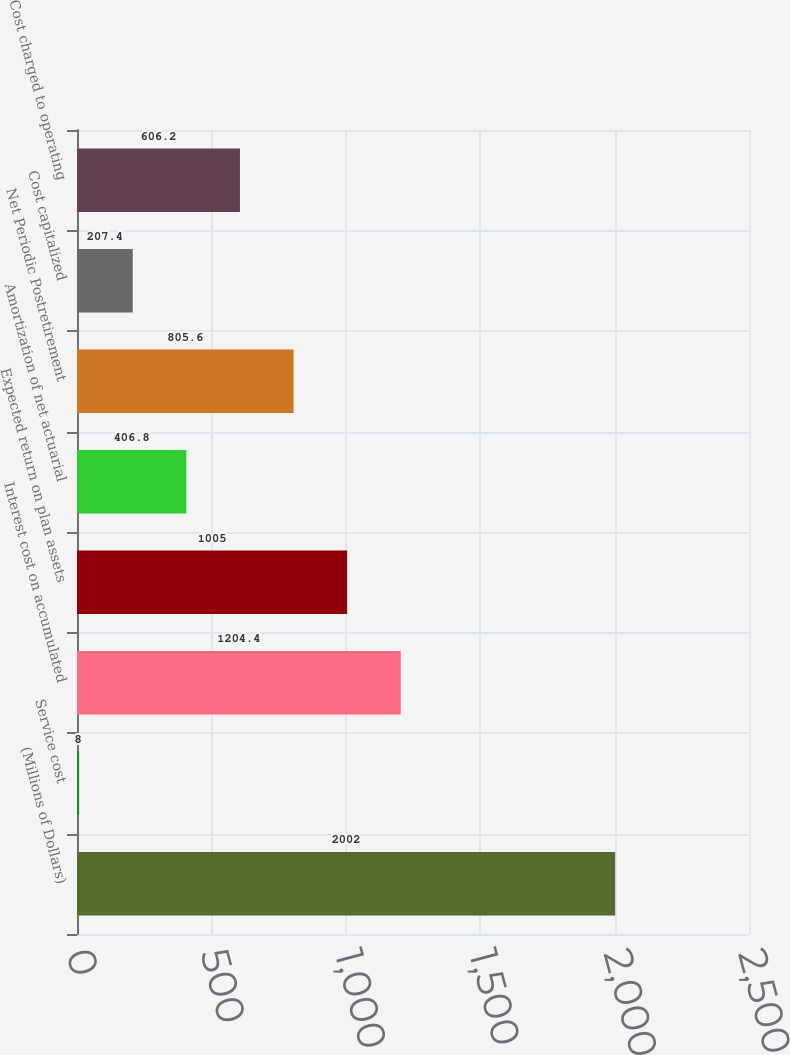<chart> <loc_0><loc_0><loc_500><loc_500><bar_chart><fcel>(Millions of Dollars)<fcel>Service cost<fcel>Interest cost on accumulated<fcel>Expected return on plan assets<fcel>Amortization of net actuarial<fcel>Net Periodic Postretirement<fcel>Cost capitalized<fcel>Cost charged to operating<nl><fcel>2002<fcel>8<fcel>1204.4<fcel>1005<fcel>406.8<fcel>805.6<fcel>207.4<fcel>606.2<nl></chart> 